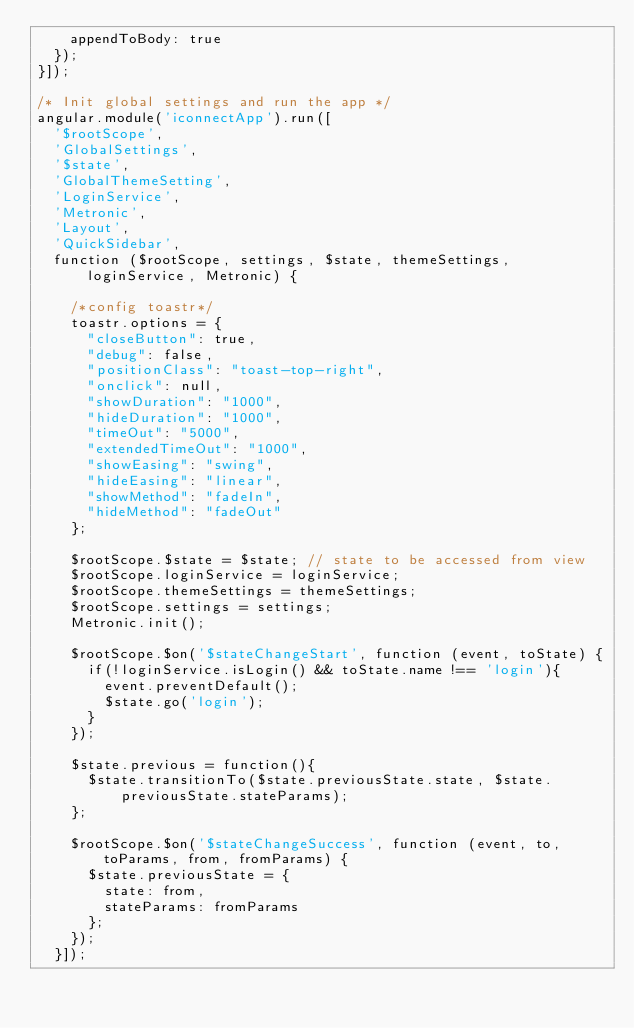<code> <loc_0><loc_0><loc_500><loc_500><_JavaScript_>    appendToBody: true
  });
}]);

/* Init global settings and run the app */
angular.module('iconnectApp').run([
  '$rootScope',
  'GlobalSettings',
  '$state',
  'GlobalThemeSetting',
  'LoginService',
  'Metronic',
  'Layout',
  'QuickSidebar',
  function ($rootScope, settings, $state, themeSettings, loginService, Metronic) {

    /*config toastr*/
    toastr.options = {
      "closeButton": true,
      "debug": false,
      "positionClass": "toast-top-right",
      "onclick": null,
      "showDuration": "1000",
      "hideDuration": "1000",
      "timeOut": "5000",
      "extendedTimeOut": "1000",
      "showEasing": "swing",
      "hideEasing": "linear",
      "showMethod": "fadeIn",
      "hideMethod": "fadeOut"
    };

    $rootScope.$state = $state; // state to be accessed from view
    $rootScope.loginService = loginService;
    $rootScope.themeSettings = themeSettings;
    $rootScope.settings = settings;
    Metronic.init();

    $rootScope.$on('$stateChangeStart', function (event, toState) {
      if(!loginService.isLogin() && toState.name !== 'login'){
        event.preventDefault();
        $state.go('login');
      }
    });

    $state.previous = function(){
      $state.transitionTo($state.previousState.state, $state.previousState.stateParams);
    };

    $rootScope.$on('$stateChangeSuccess', function (event, to, toParams, from, fromParams) {
      $state.previousState = {
        state: from,
        stateParams: fromParams
      };
    });
  }]);

</code> 